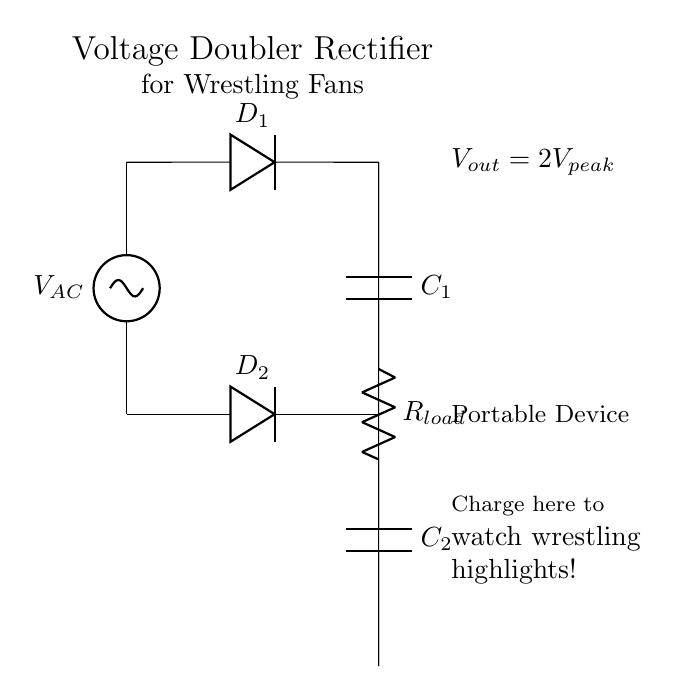What is the output voltage of this circuit? The output voltage is designated as 2Vpeak, which indicates that the output voltage is double the peak voltage of the input AC source. This is a characteristic feature of a voltage doubler circuit.
Answer: 2Vpeak What types of components are used in this circuit? The circuit utilizes diodes, capacitors, a resistor, and an AC voltage source. Each of these components plays a specific role in regulating and transforming voltage within the circuit.
Answer: Diodes, capacitors, resistor, AC source How many diodes are present in this circuit? There are two diodes labeled D1 and D2 in the circuit diagram. Each diode conducts current in one direction, contributing to the rectification process.
Answer: Two What is the role of the capacitors in this circuit? The capacitors C1 and C2 store charge and help maintain the output voltage level by smoothing out the fluctuations that result from rectification, ensuring that the connected load receives a steady voltage.
Answer: Smoothing output voltage What will happen to the output voltage if the AC input voltage increases? If the AC input voltage increases, the peak voltage also increases, leading to a proportional increase in the output voltage, which remains 2 times the new peak voltage of AC input.
Answer: Output voltage will increase What does the load resistor represent in this circuit? The load resistor Rload represents the portable device that is being charged, indicating how the current is being consumed from the output of the voltage doubler.
Answer: Portable device 